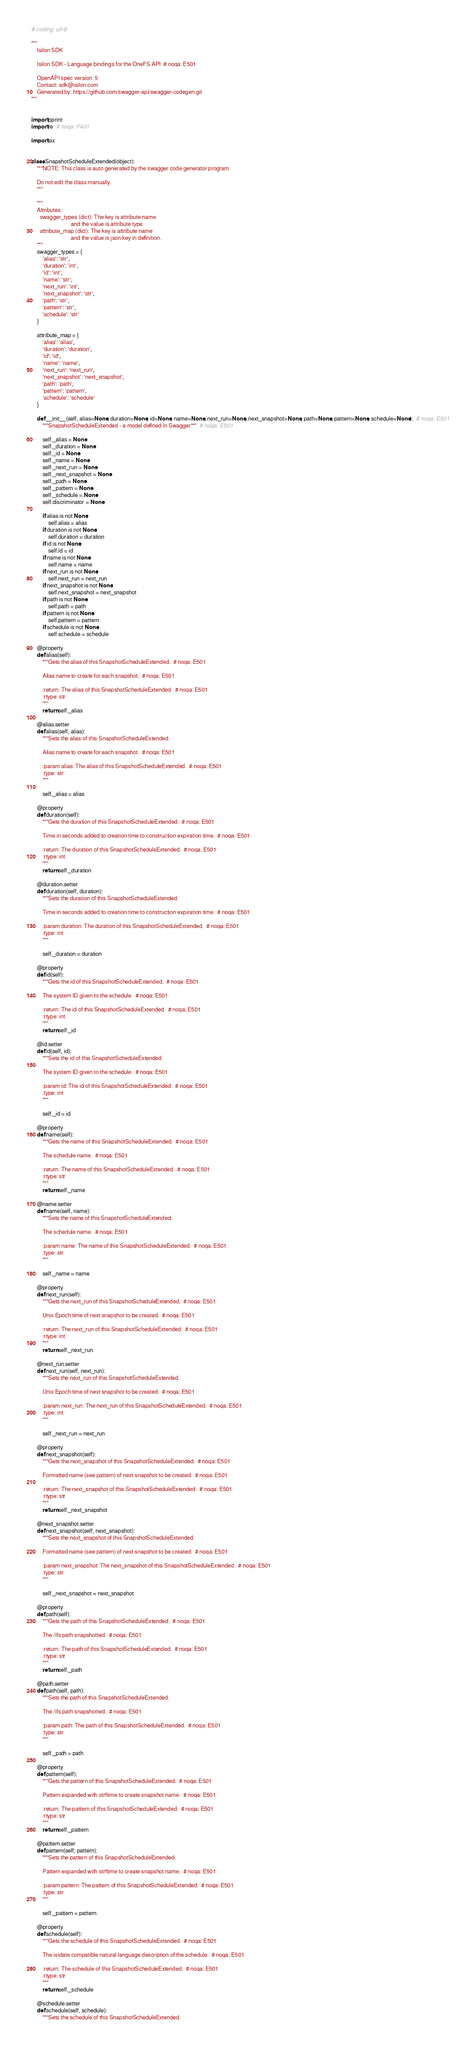Convert code to text. <code><loc_0><loc_0><loc_500><loc_500><_Python_># coding: utf-8

"""
    Isilon SDK

    Isilon SDK - Language bindings for the OneFS API  # noqa: E501

    OpenAPI spec version: 5
    Contact: sdk@isilon.com
    Generated by: https://github.com/swagger-api/swagger-codegen.git
"""


import pprint
import re  # noqa: F401

import six


class SnapshotScheduleExtended(object):
    """NOTE: This class is auto generated by the swagger code generator program.

    Do not edit the class manually.
    """

    """
    Attributes:
      swagger_types (dict): The key is attribute name
                            and the value is attribute type.
      attribute_map (dict): The key is attribute name
                            and the value is json key in definition.
    """
    swagger_types = {
        'alias': 'str',
        'duration': 'int',
        'id': 'int',
        'name': 'str',
        'next_run': 'int',
        'next_snapshot': 'str',
        'path': 'str',
        'pattern': 'str',
        'schedule': 'str'
    }

    attribute_map = {
        'alias': 'alias',
        'duration': 'duration',
        'id': 'id',
        'name': 'name',
        'next_run': 'next_run',
        'next_snapshot': 'next_snapshot',
        'path': 'path',
        'pattern': 'pattern',
        'schedule': 'schedule'
    }

    def __init__(self, alias=None, duration=None, id=None, name=None, next_run=None, next_snapshot=None, path=None, pattern=None, schedule=None):  # noqa: E501
        """SnapshotScheduleExtended - a model defined in Swagger"""  # noqa: E501

        self._alias = None
        self._duration = None
        self._id = None
        self._name = None
        self._next_run = None
        self._next_snapshot = None
        self._path = None
        self._pattern = None
        self._schedule = None
        self.discriminator = None

        if alias is not None:
            self.alias = alias
        if duration is not None:
            self.duration = duration
        if id is not None:
            self.id = id
        if name is not None:
            self.name = name
        if next_run is not None:
            self.next_run = next_run
        if next_snapshot is not None:
            self.next_snapshot = next_snapshot
        if path is not None:
            self.path = path
        if pattern is not None:
            self.pattern = pattern
        if schedule is not None:
            self.schedule = schedule

    @property
    def alias(self):
        """Gets the alias of this SnapshotScheduleExtended.  # noqa: E501

        Alias name to create for each snapshot.  # noqa: E501

        :return: The alias of this SnapshotScheduleExtended.  # noqa: E501
        :rtype: str
        """
        return self._alias

    @alias.setter
    def alias(self, alias):
        """Sets the alias of this SnapshotScheduleExtended.

        Alias name to create for each snapshot.  # noqa: E501

        :param alias: The alias of this SnapshotScheduleExtended.  # noqa: E501
        :type: str
        """

        self._alias = alias

    @property
    def duration(self):
        """Gets the duration of this SnapshotScheduleExtended.  # noqa: E501

        Time in seconds added to creation time to construction expiration time.  # noqa: E501

        :return: The duration of this SnapshotScheduleExtended.  # noqa: E501
        :rtype: int
        """
        return self._duration

    @duration.setter
    def duration(self, duration):
        """Sets the duration of this SnapshotScheduleExtended.

        Time in seconds added to creation time to construction expiration time.  # noqa: E501

        :param duration: The duration of this SnapshotScheduleExtended.  # noqa: E501
        :type: int
        """

        self._duration = duration

    @property
    def id(self):
        """Gets the id of this SnapshotScheduleExtended.  # noqa: E501

        The system ID given to the schedule.  # noqa: E501

        :return: The id of this SnapshotScheduleExtended.  # noqa: E501
        :rtype: int
        """
        return self._id

    @id.setter
    def id(self, id):
        """Sets the id of this SnapshotScheduleExtended.

        The system ID given to the schedule.  # noqa: E501

        :param id: The id of this SnapshotScheduleExtended.  # noqa: E501
        :type: int
        """

        self._id = id

    @property
    def name(self):
        """Gets the name of this SnapshotScheduleExtended.  # noqa: E501

        The schedule name.  # noqa: E501

        :return: The name of this SnapshotScheduleExtended.  # noqa: E501
        :rtype: str
        """
        return self._name

    @name.setter
    def name(self, name):
        """Sets the name of this SnapshotScheduleExtended.

        The schedule name.  # noqa: E501

        :param name: The name of this SnapshotScheduleExtended.  # noqa: E501
        :type: str
        """

        self._name = name

    @property
    def next_run(self):
        """Gets the next_run of this SnapshotScheduleExtended.  # noqa: E501

        Unix Epoch time of next snapshot to be created.  # noqa: E501

        :return: The next_run of this SnapshotScheduleExtended.  # noqa: E501
        :rtype: int
        """
        return self._next_run

    @next_run.setter
    def next_run(self, next_run):
        """Sets the next_run of this SnapshotScheduleExtended.

        Unix Epoch time of next snapshot to be created.  # noqa: E501

        :param next_run: The next_run of this SnapshotScheduleExtended.  # noqa: E501
        :type: int
        """

        self._next_run = next_run

    @property
    def next_snapshot(self):
        """Gets the next_snapshot of this SnapshotScheduleExtended.  # noqa: E501

        Formatted name (see pattern) of next snapshot to be created.  # noqa: E501

        :return: The next_snapshot of this SnapshotScheduleExtended.  # noqa: E501
        :rtype: str
        """
        return self._next_snapshot

    @next_snapshot.setter
    def next_snapshot(self, next_snapshot):
        """Sets the next_snapshot of this SnapshotScheduleExtended.

        Formatted name (see pattern) of next snapshot to be created.  # noqa: E501

        :param next_snapshot: The next_snapshot of this SnapshotScheduleExtended.  # noqa: E501
        :type: str
        """

        self._next_snapshot = next_snapshot

    @property
    def path(self):
        """Gets the path of this SnapshotScheduleExtended.  # noqa: E501

        The /ifs path snapshotted.  # noqa: E501

        :return: The path of this SnapshotScheduleExtended.  # noqa: E501
        :rtype: str
        """
        return self._path

    @path.setter
    def path(self, path):
        """Sets the path of this SnapshotScheduleExtended.

        The /ifs path snapshotted.  # noqa: E501

        :param path: The path of this SnapshotScheduleExtended.  # noqa: E501
        :type: str
        """

        self._path = path

    @property
    def pattern(self):
        """Gets the pattern of this SnapshotScheduleExtended.  # noqa: E501

        Pattern expanded with strftime to create snapshot name.  # noqa: E501

        :return: The pattern of this SnapshotScheduleExtended.  # noqa: E501
        :rtype: str
        """
        return self._pattern

    @pattern.setter
    def pattern(self, pattern):
        """Sets the pattern of this SnapshotScheduleExtended.

        Pattern expanded with strftime to create snapshot name.  # noqa: E501

        :param pattern: The pattern of this SnapshotScheduleExtended.  # noqa: E501
        :type: str
        """

        self._pattern = pattern

    @property
    def schedule(self):
        """Gets the schedule of this SnapshotScheduleExtended.  # noqa: E501

        The isidate compatible natural language description of the schedule.  # noqa: E501

        :return: The schedule of this SnapshotScheduleExtended.  # noqa: E501
        :rtype: str
        """
        return self._schedule

    @schedule.setter
    def schedule(self, schedule):
        """Sets the schedule of this SnapshotScheduleExtended.
</code> 